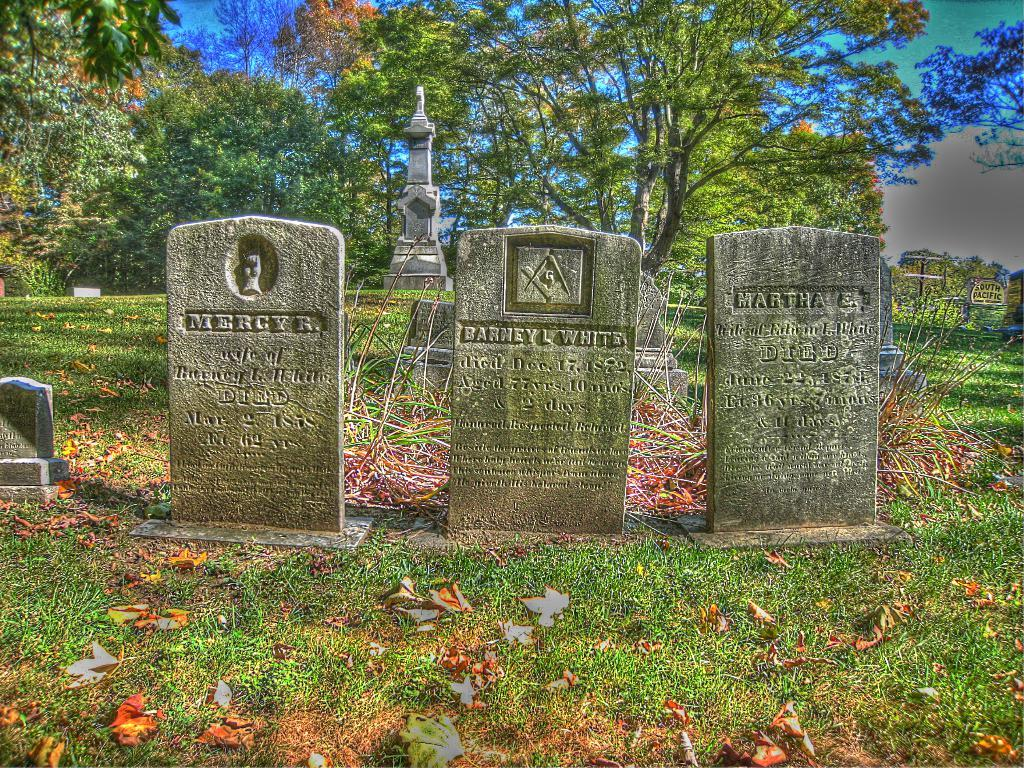What type of structures can be seen in the image? There are graveyard stones in the image. What is covering the ground in the image? There is grass on the ground in the image. What type of vegetation is visible in the image? There are trees at the top of the image. What type of bean is growing on the graveyard stones in the image? There are no beans present in the image; it features graveyard stones, grass, and trees. 